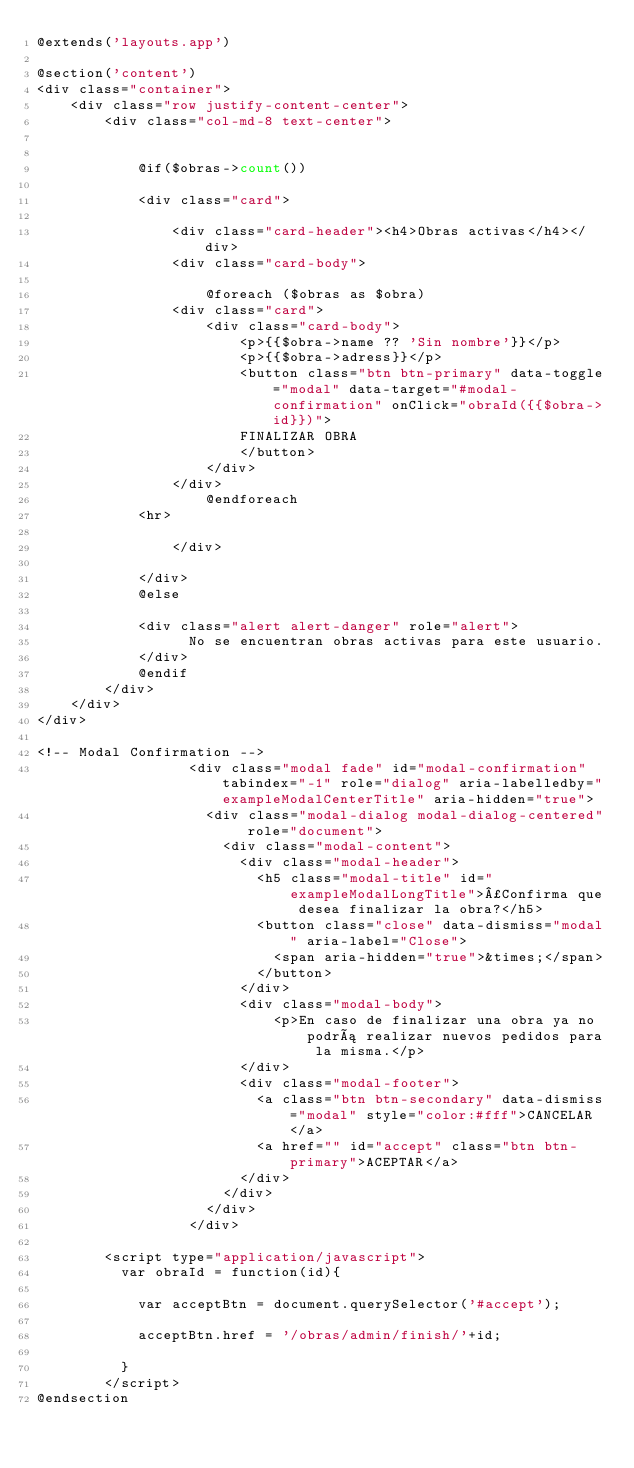Convert code to text. <code><loc_0><loc_0><loc_500><loc_500><_PHP_>@extends('layouts.app')

@section('content')
<div class="container">
    <div class="row justify-content-center">
        <div class="col-md-8 text-center">


            @if($obras->count())

            <div class="card">

                <div class="card-header"><h4>Obras activas</h4></div>
                <div class="card-body">
                    
                    @foreach ($obras as $obra)
                <div class="card">
                    <div class="card-body">
                        <p>{{$obra->name ?? 'Sin nombre'}}</p>
                        <p>{{$obra->adress}}</p>
                        <button class="btn btn-primary" data-toggle="modal" data-target="#modal-confirmation" onClick="obraId({{$obra->id}})">
                        FINALIZAR OBRA
                        </button>
                    </div>
                </div>
                    @endforeach
            <hr>

                </div>
                
            </div>
            @else

            <div class="alert alert-danger" role="alert">
                  No se encuentran obras activas para este usuario.
            </div>
            @endif
        </div>
    </div>
</div>

<!-- Modal Confirmation -->
                  <div class="modal fade" id="modal-confirmation" tabindex="-1" role="dialog" aria-labelledby="exampleModalCenterTitle" aria-hidden="true">
                    <div class="modal-dialog modal-dialog-centered" role="document">
                      <div class="modal-content">
                        <div class="modal-header">
                          <h5 class="modal-title" id="exampleModalLongTitle">¿Confirma que desea finalizar la obra?</h5>
                          <button class="close" data-dismiss="modal" aria-label="Close">
                            <span aria-hidden="true">&times;</span>
                          </button>
                        </div>
                        <div class="modal-body">
                            <p>En caso de finalizar una obra ya no podrá realizar nuevos pedidos para la misma.</p>
                        </div>
                        <div class="modal-footer">
                          <a class="btn btn-secondary" data-dismiss="modal" style="color:#fff">CANCELAR</a>
                          <a href="" id="accept" class="btn btn-primary">ACEPTAR</a>
                        </div>
                      </div>
                    </div>
                  </div>

        <script type="application/javascript">
          var obraId = function(id){

            var acceptBtn = document.querySelector('#accept');

            acceptBtn.href = '/obras/admin/finish/'+id;

          }
        </script>
@endsection
</code> 